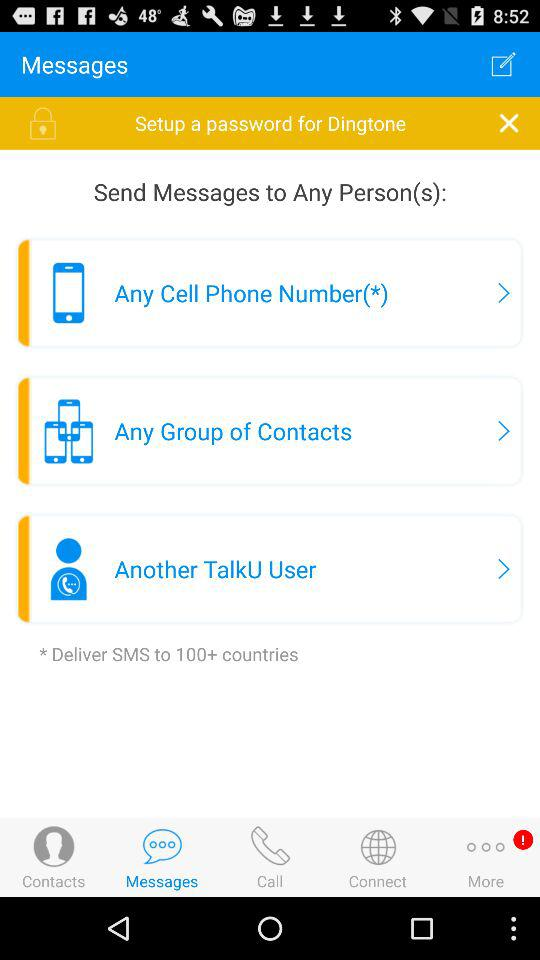Which tab is selected? The selected tab is "Messages". 